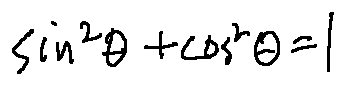Convert formula to latex. <formula><loc_0><loc_0><loc_500><loc_500>\sin ^ { 2 } \theta + \cos ^ { 2 } \theta = 1</formula> 